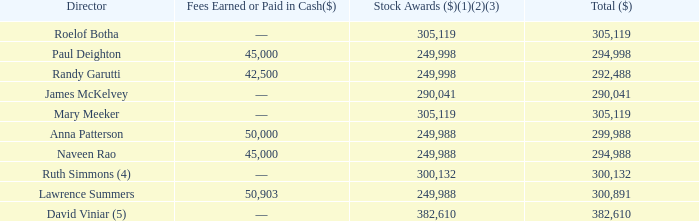2018 Compensation
The following table provides information regarding the total compensation that was earned by each of our non-employee directors in 2018.
(1) The amounts included in the “Stock Awards” column represent the aggregate grant date fair value of RSU awards calculated in accordance with Financial Accounting Standards Board Accounting Standards Codification Topic 718 (“ASC 718”). The amount does not necessarily correspond to the actual value recognized by the non-employee director. The valuation assumptions used in determining such amounts are described in the Notes to the Consolidated Financial Statements included in our Annual Report on Form 10-K for the fiscal year ended December 31, 2018.
(2) The amounts included in the “Stock Awards” column representing the annual awards or initial awards, as applicable, granted to our non-employee directors in 2018 are detailed below. Each of these awards vests and settles on the earlier of the first anniversary of the grant date or the date of our Annual Meeting, subject to the director’s continued service through the vesting date.
(3) The amounts included in the “Stock Awards” column representing the awards of RSUs granted to our non-employee directors in lieu of cash retainers in 2018 are described below. Each of these awards vested and settled in full on the grant date.
(4)  As of December 31, 2018, Dr. Simmons also held a fully vested option to purchase 38,000 shares of our Class B common stock.
(5)  As of December 31, 2018, Mr. Viniar also held 8,750 RSUs granted in 2015 to be settled in shares of our Class B common stock, which shares vest in full on the earlier of June 21, 2019 or the 2019 annual meeting subject to Mr. Viniar’s continued service with us through such vesting date. As of December 31, 2018, Mr. Viniar also held a fully vested option to purchase 326,950 shares of our Class B common stock.
What is the total compensation earned by Roelof Botha in 2018? 305,119. What is the total compensation earned by Paul Deighton in 2018? 294,998. What information does the table provide? The total compensation that was earned by each of our non-employee directors in 2018. Which director(s) earned the largest amount of total compensation? From COL5 find the largest number and the corresponding name(s) in COL2
Answer: david viniar. Which director(s) earned the least amount of stock awards? From COL4 find the smallest number and the corresponding name(s) in COL2
Answer: paul deighton, randy garutti, anna patterson, naveen rao, lawrence summers. What is the difference in Fees Earned between Paul Deighton and Randy Garutti? 45,000-42,500
Answer: 2500. 